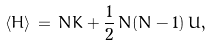Convert formula to latex. <formula><loc_0><loc_0><loc_500><loc_500>\langle H \rangle \, = \, N K + \frac { 1 } { 2 } \, N ( N - 1 ) \, U ,</formula> 